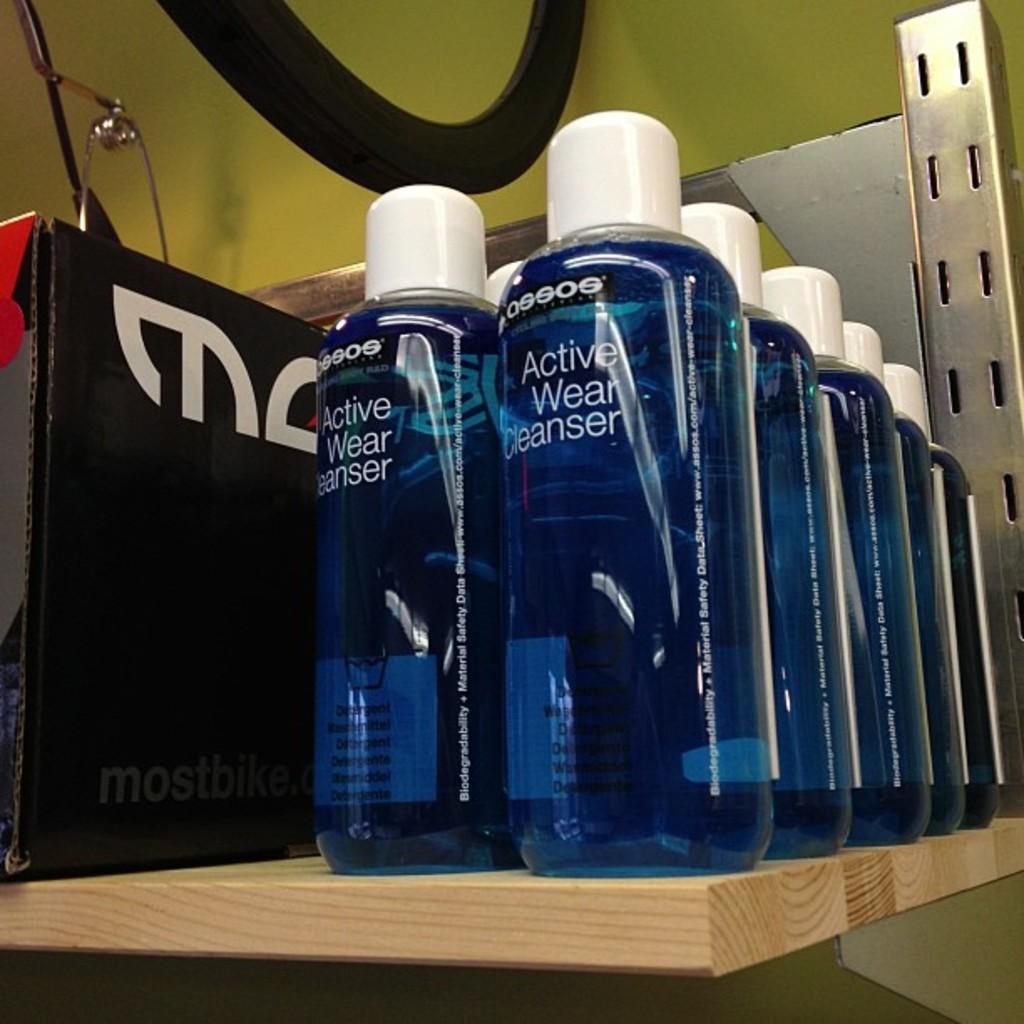What is the name of this cleanser?
Give a very brief answer. Active wear. Who makes the cleanser?
Offer a very short reply. Assos. 